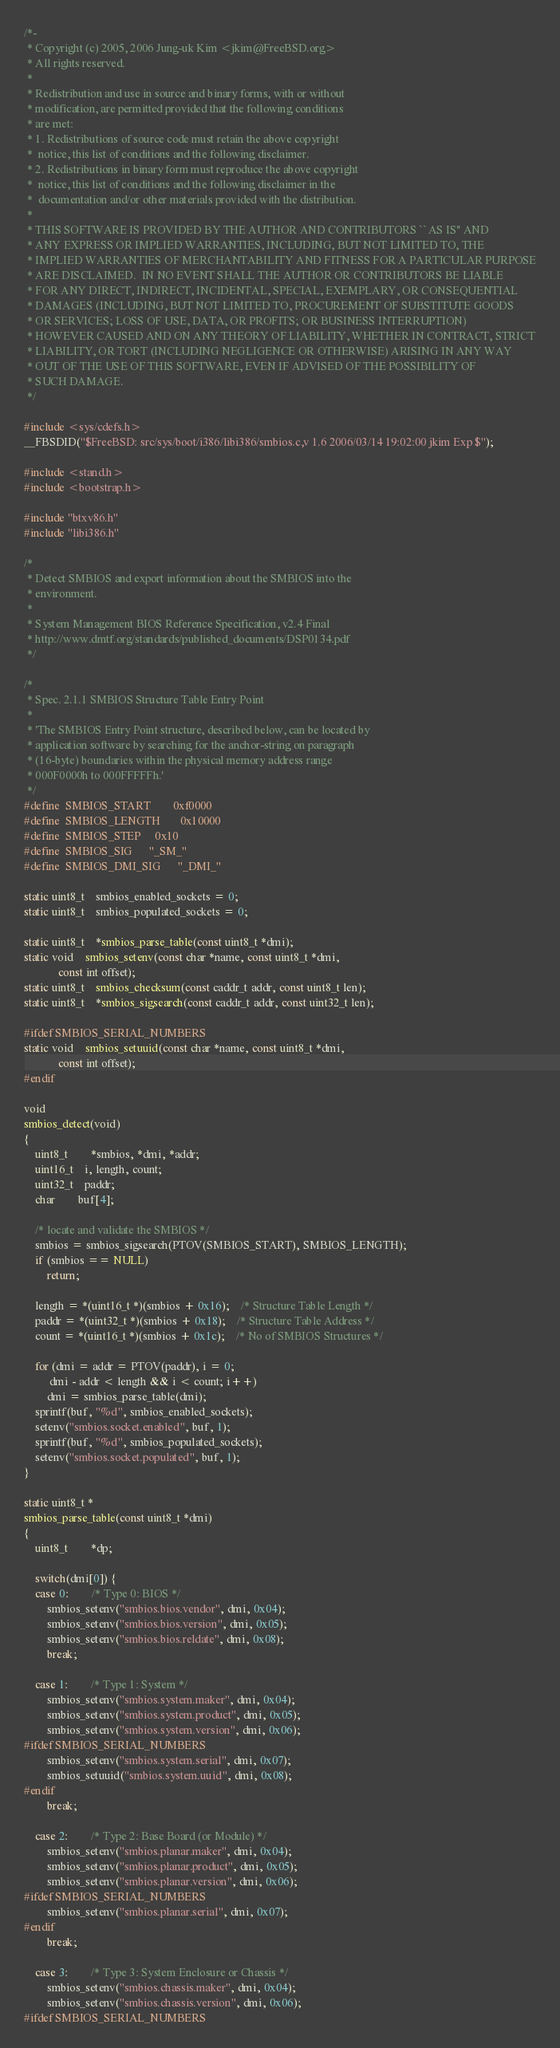Convert code to text. <code><loc_0><loc_0><loc_500><loc_500><_C_>/*-
 * Copyright (c) 2005, 2006 Jung-uk Kim <jkim@FreeBSD.org>
 * All rights reserved.
 *
 * Redistribution and use in source and binary forms, with or without
 * modification, are permitted provided that the following conditions
 * are met:
 * 1. Redistributions of source code must retain the above copyright
 *	notice, this list of conditions and the following disclaimer.
 * 2. Redistributions in binary form must reproduce the above copyright
 *	notice, this list of conditions and the following disclaimer in the
 *	documentation and/or other materials provided with the distribution.
 *
 * THIS SOFTWARE IS PROVIDED BY THE AUTHOR AND CONTRIBUTORS ``AS IS'' AND
 * ANY EXPRESS OR IMPLIED WARRANTIES, INCLUDING, BUT NOT LIMITED TO, THE
 * IMPLIED WARRANTIES OF MERCHANTABILITY AND FITNESS FOR A PARTICULAR PURPOSE
 * ARE DISCLAIMED.  IN NO EVENT SHALL THE AUTHOR OR CONTRIBUTORS BE LIABLE
 * FOR ANY DIRECT, INDIRECT, INCIDENTAL, SPECIAL, EXEMPLARY, OR CONSEQUENTIAL
 * DAMAGES (INCLUDING, BUT NOT LIMITED TO, PROCUREMENT OF SUBSTITUTE GOODS
 * OR SERVICES; LOSS OF USE, DATA, OR PROFITS; OR BUSINESS INTERRUPTION)
 * HOWEVER CAUSED AND ON ANY THEORY OF LIABILITY, WHETHER IN CONTRACT, STRICT
 * LIABILITY, OR TORT (INCLUDING NEGLIGENCE OR OTHERWISE) ARISING IN ANY WAY
 * OUT OF THE USE OF THIS SOFTWARE, EVEN IF ADVISED OF THE POSSIBILITY OF
 * SUCH DAMAGE.
 */

#include <sys/cdefs.h>
__FBSDID("$FreeBSD: src/sys/boot/i386/libi386/smbios.c,v 1.6 2006/03/14 19:02:00 jkim Exp $");

#include <stand.h>
#include <bootstrap.h>

#include "btxv86.h"
#include "libi386.h"

/*
 * Detect SMBIOS and export information about the SMBIOS into the
 * environment.
 *
 * System Management BIOS Reference Specification, v2.4 Final
 * http://www.dmtf.org/standards/published_documents/DSP0134.pdf
 */

/*
 * Spec. 2.1.1 SMBIOS Structure Table Entry Point
 *
 * 'The SMBIOS Entry Point structure, described below, can be located by
 * application software by searching for the anchor-string on paragraph
 * (16-byte) boundaries within the physical memory address range
 * 000F0000h to 000FFFFFh.'
 */
#define	SMBIOS_START		0xf0000
#define	SMBIOS_LENGTH		0x10000
#define	SMBIOS_STEP		0x10
#define	SMBIOS_SIG		"_SM_"
#define	SMBIOS_DMI_SIG		"_DMI_"

static uint8_t	smbios_enabled_sockets = 0;
static uint8_t	smbios_populated_sockets = 0;

static uint8_t	*smbios_parse_table(const uint8_t *dmi);
static void	smbios_setenv(const char *name, const uint8_t *dmi,
		    const int offset);
static uint8_t	smbios_checksum(const caddr_t addr, const uint8_t len);
static uint8_t	*smbios_sigsearch(const caddr_t addr, const uint32_t len);

#ifdef SMBIOS_SERIAL_NUMBERS
static void	smbios_setuuid(const char *name, const uint8_t *dmi,
		    const int offset);
#endif

void
smbios_detect(void)
{
	uint8_t		*smbios, *dmi, *addr;
	uint16_t	i, length, count;
	uint32_t	paddr;
	char		buf[4];

	/* locate and validate the SMBIOS */
	smbios = smbios_sigsearch(PTOV(SMBIOS_START), SMBIOS_LENGTH);
	if (smbios == NULL)
		return;

	length = *(uint16_t *)(smbios + 0x16);	/* Structure Table Length */
	paddr = *(uint32_t *)(smbios + 0x18);	/* Structure Table Address */
	count = *(uint16_t *)(smbios + 0x1c);	/* No of SMBIOS Structures */

	for (dmi = addr = PTOV(paddr), i = 0;
	     dmi - addr < length && i < count; i++)
		dmi = smbios_parse_table(dmi);
	sprintf(buf, "%d", smbios_enabled_sockets);
	setenv("smbios.socket.enabled", buf, 1);
	sprintf(buf, "%d", smbios_populated_sockets);
	setenv("smbios.socket.populated", buf, 1);
}

static uint8_t *
smbios_parse_table(const uint8_t *dmi)
{
	uint8_t		*dp;

	switch(dmi[0]) {
	case 0:		/* Type 0: BIOS */
		smbios_setenv("smbios.bios.vendor", dmi, 0x04);
		smbios_setenv("smbios.bios.version", dmi, 0x05);
		smbios_setenv("smbios.bios.reldate", dmi, 0x08);
		break;

	case 1:		/* Type 1: System */
		smbios_setenv("smbios.system.maker", dmi, 0x04);
		smbios_setenv("smbios.system.product", dmi, 0x05);
		smbios_setenv("smbios.system.version", dmi, 0x06);
#ifdef SMBIOS_SERIAL_NUMBERS
		smbios_setenv("smbios.system.serial", dmi, 0x07);
		smbios_setuuid("smbios.system.uuid", dmi, 0x08);
#endif
		break;

	case 2:		/* Type 2: Base Board (or Module) */
		smbios_setenv("smbios.planar.maker", dmi, 0x04);
		smbios_setenv("smbios.planar.product", dmi, 0x05);
		smbios_setenv("smbios.planar.version", dmi, 0x06);
#ifdef SMBIOS_SERIAL_NUMBERS
		smbios_setenv("smbios.planar.serial", dmi, 0x07);
#endif
		break;

	case 3:		/* Type 3: System Enclosure or Chassis */
		smbios_setenv("smbios.chassis.maker", dmi, 0x04);
		smbios_setenv("smbios.chassis.version", dmi, 0x06);
#ifdef SMBIOS_SERIAL_NUMBERS</code> 